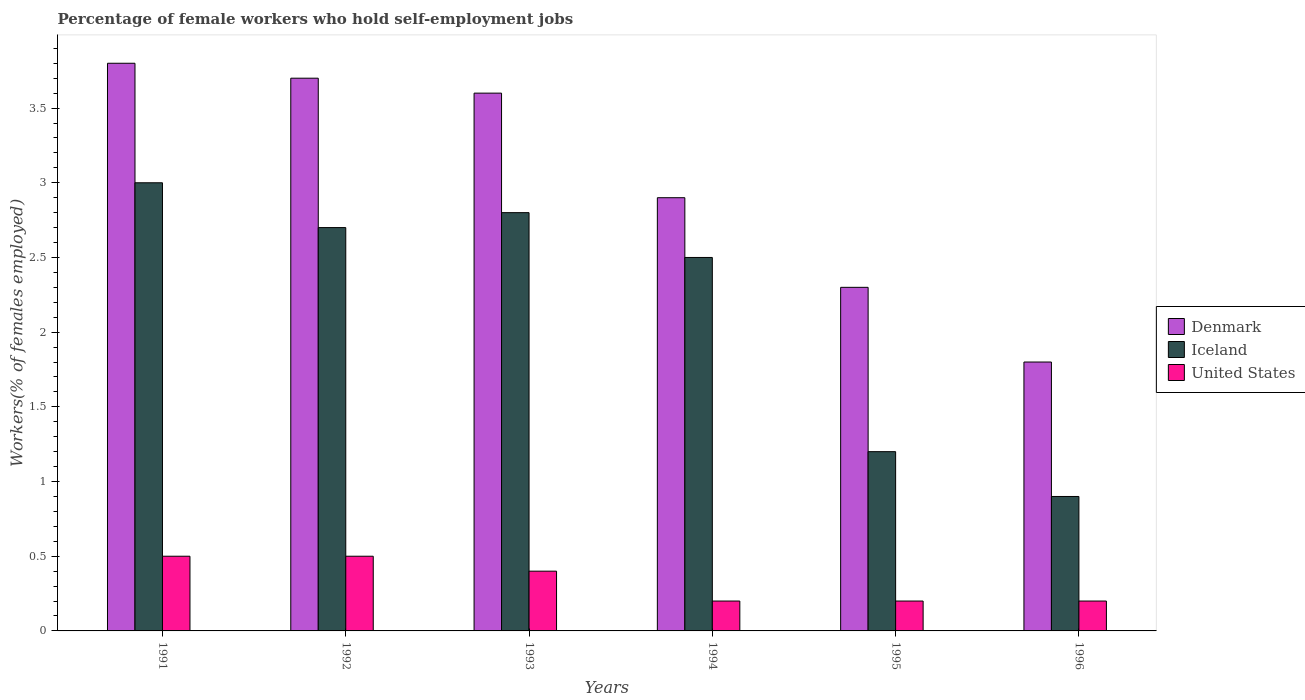Are the number of bars per tick equal to the number of legend labels?
Your answer should be compact. Yes. Are the number of bars on each tick of the X-axis equal?
Make the answer very short. Yes. How many bars are there on the 6th tick from the left?
Your answer should be very brief. 3. How many bars are there on the 4th tick from the right?
Ensure brevity in your answer.  3. What is the percentage of self-employed female workers in Iceland in 1993?
Ensure brevity in your answer.  2.8. Across all years, what is the minimum percentage of self-employed female workers in Iceland?
Provide a short and direct response. 0.9. In which year was the percentage of self-employed female workers in Iceland maximum?
Keep it short and to the point. 1991. In which year was the percentage of self-employed female workers in Iceland minimum?
Ensure brevity in your answer.  1996. What is the total percentage of self-employed female workers in United States in the graph?
Your answer should be compact. 2. What is the difference between the percentage of self-employed female workers in Denmark in 1995 and that in 1996?
Ensure brevity in your answer.  0.5. What is the difference between the percentage of self-employed female workers in United States in 1993 and the percentage of self-employed female workers in Denmark in 1996?
Make the answer very short. -1.4. What is the average percentage of self-employed female workers in United States per year?
Provide a short and direct response. 0.33. In the year 1993, what is the difference between the percentage of self-employed female workers in Iceland and percentage of self-employed female workers in Denmark?
Your answer should be compact. -0.8. In how many years, is the percentage of self-employed female workers in Denmark greater than 0.7 %?
Your answer should be compact. 6. What is the ratio of the percentage of self-employed female workers in United States in 1992 to that in 1995?
Offer a terse response. 2.5. Is the percentage of self-employed female workers in Iceland in 1992 less than that in 1994?
Provide a succinct answer. No. Is the difference between the percentage of self-employed female workers in Iceland in 1991 and 1995 greater than the difference between the percentage of self-employed female workers in Denmark in 1991 and 1995?
Offer a terse response. Yes. What is the difference between the highest and the second highest percentage of self-employed female workers in United States?
Give a very brief answer. 0. What is the difference between the highest and the lowest percentage of self-employed female workers in Iceland?
Provide a short and direct response. 2.1. In how many years, is the percentage of self-employed female workers in Denmark greater than the average percentage of self-employed female workers in Denmark taken over all years?
Your answer should be very brief. 3. Is the sum of the percentage of self-employed female workers in United States in 1992 and 1993 greater than the maximum percentage of self-employed female workers in Denmark across all years?
Provide a succinct answer. No. What does the 2nd bar from the left in 1996 represents?
Your answer should be very brief. Iceland. What does the 3rd bar from the right in 1993 represents?
Ensure brevity in your answer.  Denmark. Is it the case that in every year, the sum of the percentage of self-employed female workers in Iceland and percentage of self-employed female workers in Denmark is greater than the percentage of self-employed female workers in United States?
Your response must be concise. Yes. How many bars are there?
Provide a succinct answer. 18. Are all the bars in the graph horizontal?
Ensure brevity in your answer.  No. How many years are there in the graph?
Ensure brevity in your answer.  6. What is the difference between two consecutive major ticks on the Y-axis?
Ensure brevity in your answer.  0.5. Are the values on the major ticks of Y-axis written in scientific E-notation?
Ensure brevity in your answer.  No. How many legend labels are there?
Provide a succinct answer. 3. What is the title of the graph?
Provide a succinct answer. Percentage of female workers who hold self-employment jobs. What is the label or title of the X-axis?
Provide a succinct answer. Years. What is the label or title of the Y-axis?
Offer a terse response. Workers(% of females employed). What is the Workers(% of females employed) of Denmark in 1991?
Keep it short and to the point. 3.8. What is the Workers(% of females employed) in Denmark in 1992?
Your response must be concise. 3.7. What is the Workers(% of females employed) of Iceland in 1992?
Your answer should be very brief. 2.7. What is the Workers(% of females employed) in United States in 1992?
Offer a terse response. 0.5. What is the Workers(% of females employed) in Denmark in 1993?
Make the answer very short. 3.6. What is the Workers(% of females employed) of Iceland in 1993?
Keep it short and to the point. 2.8. What is the Workers(% of females employed) of United States in 1993?
Your answer should be compact. 0.4. What is the Workers(% of females employed) in Denmark in 1994?
Your answer should be very brief. 2.9. What is the Workers(% of females employed) in United States in 1994?
Provide a succinct answer. 0.2. What is the Workers(% of females employed) in Denmark in 1995?
Give a very brief answer. 2.3. What is the Workers(% of females employed) of Iceland in 1995?
Keep it short and to the point. 1.2. What is the Workers(% of females employed) in United States in 1995?
Provide a succinct answer. 0.2. What is the Workers(% of females employed) of Denmark in 1996?
Provide a short and direct response. 1.8. What is the Workers(% of females employed) of Iceland in 1996?
Offer a very short reply. 0.9. What is the Workers(% of females employed) of United States in 1996?
Provide a short and direct response. 0.2. Across all years, what is the maximum Workers(% of females employed) of Denmark?
Provide a short and direct response. 3.8. Across all years, what is the maximum Workers(% of females employed) in United States?
Offer a terse response. 0.5. Across all years, what is the minimum Workers(% of females employed) of Denmark?
Offer a terse response. 1.8. Across all years, what is the minimum Workers(% of females employed) in Iceland?
Make the answer very short. 0.9. Across all years, what is the minimum Workers(% of females employed) in United States?
Your response must be concise. 0.2. What is the total Workers(% of females employed) in Denmark in the graph?
Ensure brevity in your answer.  18.1. What is the difference between the Workers(% of females employed) of United States in 1991 and that in 1992?
Offer a very short reply. 0. What is the difference between the Workers(% of females employed) of United States in 1991 and that in 1993?
Provide a succinct answer. 0.1. What is the difference between the Workers(% of females employed) of Denmark in 1991 and that in 1994?
Offer a very short reply. 0.9. What is the difference between the Workers(% of females employed) in Iceland in 1991 and that in 1994?
Offer a terse response. 0.5. What is the difference between the Workers(% of females employed) in United States in 1991 and that in 1994?
Your answer should be very brief. 0.3. What is the difference between the Workers(% of females employed) in Iceland in 1991 and that in 1995?
Keep it short and to the point. 1.8. What is the difference between the Workers(% of females employed) of Denmark in 1991 and that in 1996?
Offer a very short reply. 2. What is the difference between the Workers(% of females employed) in Denmark in 1992 and that in 1993?
Your answer should be compact. 0.1. What is the difference between the Workers(% of females employed) of Iceland in 1992 and that in 1995?
Your answer should be very brief. 1.5. What is the difference between the Workers(% of females employed) of Iceland in 1992 and that in 1996?
Provide a succinct answer. 1.8. What is the difference between the Workers(% of females employed) of Denmark in 1993 and that in 1995?
Provide a short and direct response. 1.3. What is the difference between the Workers(% of females employed) in United States in 1993 and that in 1995?
Give a very brief answer. 0.2. What is the difference between the Workers(% of females employed) of Iceland in 1993 and that in 1996?
Offer a very short reply. 1.9. What is the difference between the Workers(% of females employed) of United States in 1993 and that in 1996?
Your answer should be compact. 0.2. What is the difference between the Workers(% of females employed) of Iceland in 1994 and that in 1995?
Your answer should be compact. 1.3. What is the difference between the Workers(% of females employed) in Iceland in 1994 and that in 1996?
Provide a short and direct response. 1.6. What is the difference between the Workers(% of females employed) in United States in 1994 and that in 1996?
Offer a terse response. 0. What is the difference between the Workers(% of females employed) in Iceland in 1995 and that in 1996?
Provide a short and direct response. 0.3. What is the difference between the Workers(% of females employed) of Denmark in 1991 and the Workers(% of females employed) of United States in 1992?
Provide a short and direct response. 3.3. What is the difference between the Workers(% of females employed) in Iceland in 1991 and the Workers(% of females employed) in United States in 1992?
Your response must be concise. 2.5. What is the difference between the Workers(% of females employed) of Denmark in 1991 and the Workers(% of females employed) of Iceland in 1993?
Ensure brevity in your answer.  1. What is the difference between the Workers(% of females employed) in Iceland in 1991 and the Workers(% of females employed) in United States in 1993?
Make the answer very short. 2.6. What is the difference between the Workers(% of females employed) of Denmark in 1991 and the Workers(% of females employed) of United States in 1994?
Make the answer very short. 3.6. What is the difference between the Workers(% of females employed) in Iceland in 1991 and the Workers(% of females employed) in United States in 1994?
Give a very brief answer. 2.8. What is the difference between the Workers(% of females employed) of Denmark in 1991 and the Workers(% of females employed) of Iceland in 1995?
Give a very brief answer. 2.6. What is the difference between the Workers(% of females employed) in Denmark in 1991 and the Workers(% of females employed) in United States in 1995?
Offer a terse response. 3.6. What is the difference between the Workers(% of females employed) of Denmark in 1991 and the Workers(% of females employed) of Iceland in 1996?
Provide a succinct answer. 2.9. What is the difference between the Workers(% of females employed) in Denmark in 1991 and the Workers(% of females employed) in United States in 1996?
Provide a succinct answer. 3.6. What is the difference between the Workers(% of females employed) of Iceland in 1991 and the Workers(% of females employed) of United States in 1996?
Your answer should be compact. 2.8. What is the difference between the Workers(% of females employed) of Denmark in 1992 and the Workers(% of females employed) of United States in 1993?
Offer a very short reply. 3.3. What is the difference between the Workers(% of females employed) of Iceland in 1992 and the Workers(% of females employed) of United States in 1993?
Provide a short and direct response. 2.3. What is the difference between the Workers(% of females employed) of Denmark in 1992 and the Workers(% of females employed) of Iceland in 1994?
Keep it short and to the point. 1.2. What is the difference between the Workers(% of females employed) in Iceland in 1992 and the Workers(% of females employed) in United States in 1994?
Provide a succinct answer. 2.5. What is the difference between the Workers(% of females employed) of Denmark in 1992 and the Workers(% of females employed) of Iceland in 1995?
Give a very brief answer. 2.5. What is the difference between the Workers(% of females employed) in Denmark in 1992 and the Workers(% of females employed) in United States in 1995?
Offer a very short reply. 3.5. What is the difference between the Workers(% of females employed) of Iceland in 1992 and the Workers(% of females employed) of United States in 1995?
Offer a very short reply. 2.5. What is the difference between the Workers(% of females employed) of Denmark in 1992 and the Workers(% of females employed) of United States in 1996?
Give a very brief answer. 3.5. What is the difference between the Workers(% of females employed) of Denmark in 1993 and the Workers(% of females employed) of Iceland in 1995?
Make the answer very short. 2.4. What is the difference between the Workers(% of females employed) of Denmark in 1993 and the Workers(% of females employed) of United States in 1995?
Ensure brevity in your answer.  3.4. What is the difference between the Workers(% of females employed) in Iceland in 1993 and the Workers(% of females employed) in United States in 1995?
Provide a short and direct response. 2.6. What is the difference between the Workers(% of females employed) in Iceland in 1993 and the Workers(% of females employed) in United States in 1996?
Provide a short and direct response. 2.6. What is the difference between the Workers(% of females employed) of Denmark in 1994 and the Workers(% of females employed) of United States in 1995?
Your answer should be compact. 2.7. What is the difference between the Workers(% of females employed) in Iceland in 1994 and the Workers(% of females employed) in United States in 1995?
Offer a terse response. 2.3. What is the difference between the Workers(% of females employed) in Denmark in 1994 and the Workers(% of females employed) in Iceland in 1996?
Offer a very short reply. 2. What is the difference between the Workers(% of females employed) in Denmark in 1994 and the Workers(% of females employed) in United States in 1996?
Provide a succinct answer. 2.7. What is the difference between the Workers(% of females employed) of Iceland in 1994 and the Workers(% of females employed) of United States in 1996?
Your response must be concise. 2.3. What is the difference between the Workers(% of females employed) of Denmark in 1995 and the Workers(% of females employed) of Iceland in 1996?
Give a very brief answer. 1.4. What is the difference between the Workers(% of females employed) in Denmark in 1995 and the Workers(% of females employed) in United States in 1996?
Your response must be concise. 2.1. What is the average Workers(% of females employed) in Denmark per year?
Give a very brief answer. 3.02. What is the average Workers(% of females employed) in Iceland per year?
Offer a very short reply. 2.18. In the year 1991, what is the difference between the Workers(% of females employed) in Denmark and Workers(% of females employed) in Iceland?
Provide a short and direct response. 0.8. In the year 1991, what is the difference between the Workers(% of females employed) in Denmark and Workers(% of females employed) in United States?
Your response must be concise. 3.3. In the year 1992, what is the difference between the Workers(% of females employed) in Iceland and Workers(% of females employed) in United States?
Offer a very short reply. 2.2. In the year 1993, what is the difference between the Workers(% of females employed) in Denmark and Workers(% of females employed) in Iceland?
Make the answer very short. 0.8. In the year 1993, what is the difference between the Workers(% of females employed) of Denmark and Workers(% of females employed) of United States?
Offer a very short reply. 3.2. In the year 1994, what is the difference between the Workers(% of females employed) in Denmark and Workers(% of females employed) in United States?
Make the answer very short. 2.7. In the year 1995, what is the difference between the Workers(% of females employed) in Denmark and Workers(% of females employed) in Iceland?
Offer a very short reply. 1.1. In the year 1995, what is the difference between the Workers(% of females employed) in Denmark and Workers(% of females employed) in United States?
Your response must be concise. 2.1. In the year 1995, what is the difference between the Workers(% of females employed) in Iceland and Workers(% of females employed) in United States?
Keep it short and to the point. 1. In the year 1996, what is the difference between the Workers(% of females employed) of Denmark and Workers(% of females employed) of Iceland?
Provide a succinct answer. 0.9. In the year 1996, what is the difference between the Workers(% of females employed) in Iceland and Workers(% of females employed) in United States?
Keep it short and to the point. 0.7. What is the ratio of the Workers(% of females employed) in Denmark in 1991 to that in 1993?
Offer a terse response. 1.06. What is the ratio of the Workers(% of females employed) in Iceland in 1991 to that in 1993?
Provide a short and direct response. 1.07. What is the ratio of the Workers(% of females employed) in United States in 1991 to that in 1993?
Your answer should be very brief. 1.25. What is the ratio of the Workers(% of females employed) in Denmark in 1991 to that in 1994?
Provide a short and direct response. 1.31. What is the ratio of the Workers(% of females employed) in Iceland in 1991 to that in 1994?
Your answer should be compact. 1.2. What is the ratio of the Workers(% of females employed) of Denmark in 1991 to that in 1995?
Your response must be concise. 1.65. What is the ratio of the Workers(% of females employed) in Iceland in 1991 to that in 1995?
Your answer should be very brief. 2.5. What is the ratio of the Workers(% of females employed) of Denmark in 1991 to that in 1996?
Provide a short and direct response. 2.11. What is the ratio of the Workers(% of females employed) in United States in 1991 to that in 1996?
Give a very brief answer. 2.5. What is the ratio of the Workers(% of females employed) in Denmark in 1992 to that in 1993?
Offer a terse response. 1.03. What is the ratio of the Workers(% of females employed) of Iceland in 1992 to that in 1993?
Keep it short and to the point. 0.96. What is the ratio of the Workers(% of females employed) in Denmark in 1992 to that in 1994?
Offer a very short reply. 1.28. What is the ratio of the Workers(% of females employed) in Iceland in 1992 to that in 1994?
Make the answer very short. 1.08. What is the ratio of the Workers(% of females employed) in United States in 1992 to that in 1994?
Keep it short and to the point. 2.5. What is the ratio of the Workers(% of females employed) of Denmark in 1992 to that in 1995?
Give a very brief answer. 1.61. What is the ratio of the Workers(% of females employed) in Iceland in 1992 to that in 1995?
Your answer should be compact. 2.25. What is the ratio of the Workers(% of females employed) in Denmark in 1992 to that in 1996?
Keep it short and to the point. 2.06. What is the ratio of the Workers(% of females employed) of United States in 1992 to that in 1996?
Your response must be concise. 2.5. What is the ratio of the Workers(% of females employed) of Denmark in 1993 to that in 1994?
Offer a very short reply. 1.24. What is the ratio of the Workers(% of females employed) of Iceland in 1993 to that in 1994?
Provide a succinct answer. 1.12. What is the ratio of the Workers(% of females employed) in Denmark in 1993 to that in 1995?
Offer a terse response. 1.57. What is the ratio of the Workers(% of females employed) in Iceland in 1993 to that in 1995?
Make the answer very short. 2.33. What is the ratio of the Workers(% of females employed) of Iceland in 1993 to that in 1996?
Provide a succinct answer. 3.11. What is the ratio of the Workers(% of females employed) of Denmark in 1994 to that in 1995?
Offer a very short reply. 1.26. What is the ratio of the Workers(% of females employed) in Iceland in 1994 to that in 1995?
Ensure brevity in your answer.  2.08. What is the ratio of the Workers(% of females employed) of Denmark in 1994 to that in 1996?
Offer a terse response. 1.61. What is the ratio of the Workers(% of females employed) in Iceland in 1994 to that in 1996?
Make the answer very short. 2.78. What is the ratio of the Workers(% of females employed) in Denmark in 1995 to that in 1996?
Your answer should be very brief. 1.28. What is the ratio of the Workers(% of females employed) of Iceland in 1995 to that in 1996?
Keep it short and to the point. 1.33. What is the difference between the highest and the second highest Workers(% of females employed) in United States?
Make the answer very short. 0. What is the difference between the highest and the lowest Workers(% of females employed) of Iceland?
Offer a terse response. 2.1. 